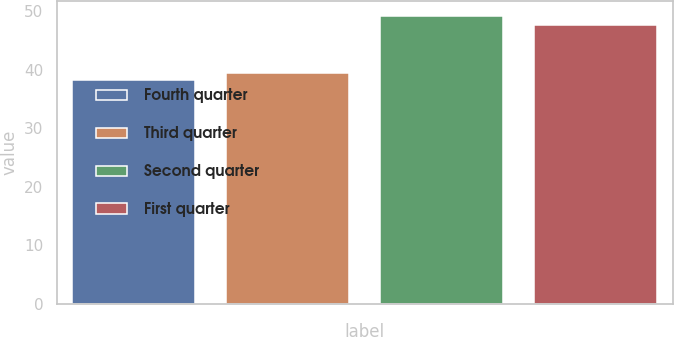Convert chart. <chart><loc_0><loc_0><loc_500><loc_500><bar_chart><fcel>Fourth quarter<fcel>Third quarter<fcel>Second quarter<fcel>First quarter<nl><fcel>38.3<fcel>39.39<fcel>49.17<fcel>47.58<nl></chart> 